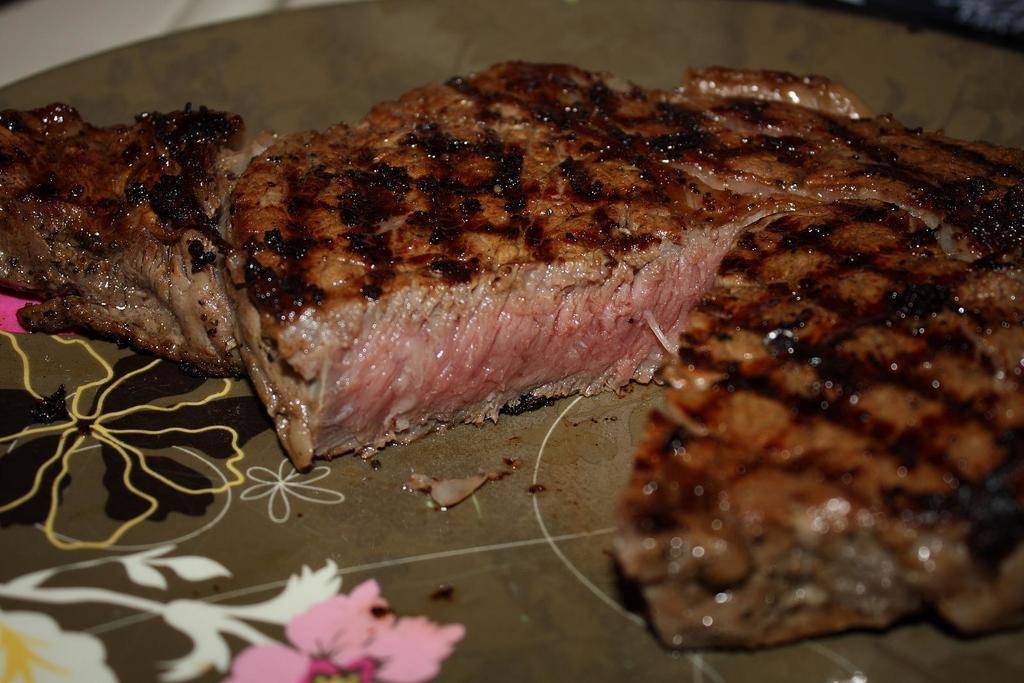Could you give a brief overview of what you see in this image? In this image we can see meat on a plate. 